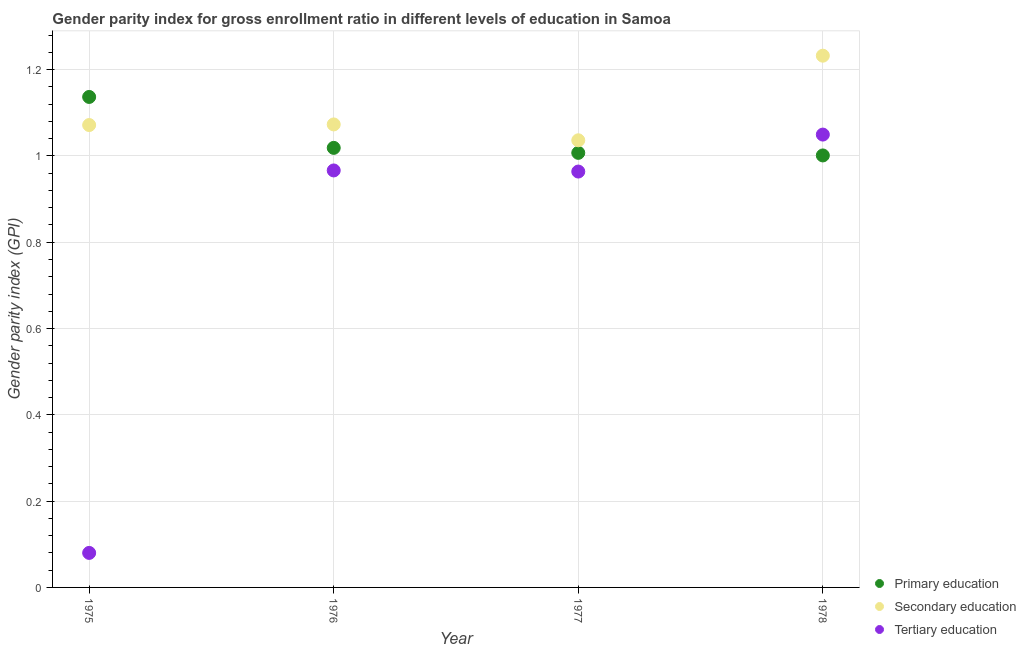How many different coloured dotlines are there?
Provide a short and direct response. 3. Is the number of dotlines equal to the number of legend labels?
Provide a succinct answer. Yes. What is the gender parity index in tertiary education in 1976?
Your answer should be compact. 0.97. Across all years, what is the maximum gender parity index in primary education?
Your answer should be compact. 1.14. Across all years, what is the minimum gender parity index in secondary education?
Provide a succinct answer. 1.04. In which year was the gender parity index in secondary education maximum?
Give a very brief answer. 1978. In which year was the gender parity index in tertiary education minimum?
Your answer should be very brief. 1975. What is the total gender parity index in primary education in the graph?
Provide a succinct answer. 4.16. What is the difference between the gender parity index in tertiary education in 1976 and that in 1977?
Your answer should be compact. 0. What is the difference between the gender parity index in primary education in 1978 and the gender parity index in tertiary education in 1977?
Give a very brief answer. 0.04. What is the average gender parity index in tertiary education per year?
Offer a very short reply. 0.76. In the year 1977, what is the difference between the gender parity index in primary education and gender parity index in tertiary education?
Your answer should be very brief. 0.04. In how many years, is the gender parity index in secondary education greater than 0.2?
Your response must be concise. 4. What is the ratio of the gender parity index in tertiary education in 1975 to that in 1976?
Keep it short and to the point. 0.08. What is the difference between the highest and the second highest gender parity index in secondary education?
Your answer should be very brief. 0.16. What is the difference between the highest and the lowest gender parity index in tertiary education?
Make the answer very short. 0.97. In how many years, is the gender parity index in primary education greater than the average gender parity index in primary education taken over all years?
Make the answer very short. 1. Is the gender parity index in tertiary education strictly greater than the gender parity index in secondary education over the years?
Offer a terse response. No. Is the gender parity index in primary education strictly less than the gender parity index in secondary education over the years?
Your answer should be compact. No. How many dotlines are there?
Ensure brevity in your answer.  3. What is the difference between two consecutive major ticks on the Y-axis?
Keep it short and to the point. 0.2. Does the graph contain any zero values?
Make the answer very short. No. Where does the legend appear in the graph?
Your answer should be very brief. Bottom right. How many legend labels are there?
Your answer should be compact. 3. What is the title of the graph?
Provide a short and direct response. Gender parity index for gross enrollment ratio in different levels of education in Samoa. What is the label or title of the Y-axis?
Give a very brief answer. Gender parity index (GPI). What is the Gender parity index (GPI) of Primary education in 1975?
Offer a very short reply. 1.14. What is the Gender parity index (GPI) in Secondary education in 1975?
Make the answer very short. 1.07. What is the Gender parity index (GPI) of Tertiary education in 1975?
Your answer should be compact. 0.08. What is the Gender parity index (GPI) of Primary education in 1976?
Offer a very short reply. 1.02. What is the Gender parity index (GPI) of Secondary education in 1976?
Keep it short and to the point. 1.07. What is the Gender parity index (GPI) of Tertiary education in 1976?
Your response must be concise. 0.97. What is the Gender parity index (GPI) of Primary education in 1977?
Your answer should be compact. 1.01. What is the Gender parity index (GPI) in Secondary education in 1977?
Keep it short and to the point. 1.04. What is the Gender parity index (GPI) in Tertiary education in 1977?
Your answer should be very brief. 0.96. What is the Gender parity index (GPI) in Primary education in 1978?
Ensure brevity in your answer.  1. What is the Gender parity index (GPI) in Secondary education in 1978?
Keep it short and to the point. 1.23. What is the Gender parity index (GPI) in Tertiary education in 1978?
Give a very brief answer. 1.05. Across all years, what is the maximum Gender parity index (GPI) of Primary education?
Offer a very short reply. 1.14. Across all years, what is the maximum Gender parity index (GPI) of Secondary education?
Provide a succinct answer. 1.23. Across all years, what is the maximum Gender parity index (GPI) in Tertiary education?
Your response must be concise. 1.05. Across all years, what is the minimum Gender parity index (GPI) in Primary education?
Offer a terse response. 1. Across all years, what is the minimum Gender parity index (GPI) in Secondary education?
Keep it short and to the point. 1.04. Across all years, what is the minimum Gender parity index (GPI) in Tertiary education?
Offer a terse response. 0.08. What is the total Gender parity index (GPI) in Primary education in the graph?
Offer a terse response. 4.16. What is the total Gender parity index (GPI) in Secondary education in the graph?
Keep it short and to the point. 4.41. What is the total Gender parity index (GPI) of Tertiary education in the graph?
Your response must be concise. 3.06. What is the difference between the Gender parity index (GPI) of Primary education in 1975 and that in 1976?
Provide a short and direct response. 0.12. What is the difference between the Gender parity index (GPI) of Secondary education in 1975 and that in 1976?
Offer a terse response. -0. What is the difference between the Gender parity index (GPI) in Tertiary education in 1975 and that in 1976?
Provide a succinct answer. -0.89. What is the difference between the Gender parity index (GPI) in Primary education in 1975 and that in 1977?
Offer a very short reply. 0.13. What is the difference between the Gender parity index (GPI) in Secondary education in 1975 and that in 1977?
Make the answer very short. 0.04. What is the difference between the Gender parity index (GPI) in Tertiary education in 1975 and that in 1977?
Ensure brevity in your answer.  -0.88. What is the difference between the Gender parity index (GPI) of Primary education in 1975 and that in 1978?
Make the answer very short. 0.14. What is the difference between the Gender parity index (GPI) of Secondary education in 1975 and that in 1978?
Your answer should be compact. -0.16. What is the difference between the Gender parity index (GPI) of Tertiary education in 1975 and that in 1978?
Ensure brevity in your answer.  -0.97. What is the difference between the Gender parity index (GPI) of Primary education in 1976 and that in 1977?
Your answer should be compact. 0.01. What is the difference between the Gender parity index (GPI) in Secondary education in 1976 and that in 1977?
Make the answer very short. 0.04. What is the difference between the Gender parity index (GPI) in Tertiary education in 1976 and that in 1977?
Keep it short and to the point. 0. What is the difference between the Gender parity index (GPI) in Primary education in 1976 and that in 1978?
Make the answer very short. 0.02. What is the difference between the Gender parity index (GPI) in Secondary education in 1976 and that in 1978?
Your response must be concise. -0.16. What is the difference between the Gender parity index (GPI) of Tertiary education in 1976 and that in 1978?
Your answer should be very brief. -0.08. What is the difference between the Gender parity index (GPI) in Primary education in 1977 and that in 1978?
Your answer should be very brief. 0.01. What is the difference between the Gender parity index (GPI) in Secondary education in 1977 and that in 1978?
Provide a short and direct response. -0.2. What is the difference between the Gender parity index (GPI) of Tertiary education in 1977 and that in 1978?
Offer a very short reply. -0.09. What is the difference between the Gender parity index (GPI) in Primary education in 1975 and the Gender parity index (GPI) in Secondary education in 1976?
Your response must be concise. 0.06. What is the difference between the Gender parity index (GPI) in Primary education in 1975 and the Gender parity index (GPI) in Tertiary education in 1976?
Offer a terse response. 0.17. What is the difference between the Gender parity index (GPI) in Secondary education in 1975 and the Gender parity index (GPI) in Tertiary education in 1976?
Your response must be concise. 0.11. What is the difference between the Gender parity index (GPI) in Primary education in 1975 and the Gender parity index (GPI) in Secondary education in 1977?
Make the answer very short. 0.1. What is the difference between the Gender parity index (GPI) in Primary education in 1975 and the Gender parity index (GPI) in Tertiary education in 1977?
Make the answer very short. 0.17. What is the difference between the Gender parity index (GPI) in Secondary education in 1975 and the Gender parity index (GPI) in Tertiary education in 1977?
Offer a very short reply. 0.11. What is the difference between the Gender parity index (GPI) of Primary education in 1975 and the Gender parity index (GPI) of Secondary education in 1978?
Ensure brevity in your answer.  -0.1. What is the difference between the Gender parity index (GPI) in Primary education in 1975 and the Gender parity index (GPI) in Tertiary education in 1978?
Make the answer very short. 0.09. What is the difference between the Gender parity index (GPI) in Secondary education in 1975 and the Gender parity index (GPI) in Tertiary education in 1978?
Offer a very short reply. 0.02. What is the difference between the Gender parity index (GPI) of Primary education in 1976 and the Gender parity index (GPI) of Secondary education in 1977?
Ensure brevity in your answer.  -0.02. What is the difference between the Gender parity index (GPI) of Primary education in 1976 and the Gender parity index (GPI) of Tertiary education in 1977?
Give a very brief answer. 0.05. What is the difference between the Gender parity index (GPI) in Secondary education in 1976 and the Gender parity index (GPI) in Tertiary education in 1977?
Give a very brief answer. 0.11. What is the difference between the Gender parity index (GPI) of Primary education in 1976 and the Gender parity index (GPI) of Secondary education in 1978?
Keep it short and to the point. -0.21. What is the difference between the Gender parity index (GPI) of Primary education in 1976 and the Gender parity index (GPI) of Tertiary education in 1978?
Provide a short and direct response. -0.03. What is the difference between the Gender parity index (GPI) of Secondary education in 1976 and the Gender parity index (GPI) of Tertiary education in 1978?
Provide a short and direct response. 0.02. What is the difference between the Gender parity index (GPI) of Primary education in 1977 and the Gender parity index (GPI) of Secondary education in 1978?
Provide a succinct answer. -0.23. What is the difference between the Gender parity index (GPI) in Primary education in 1977 and the Gender parity index (GPI) in Tertiary education in 1978?
Offer a very short reply. -0.04. What is the difference between the Gender parity index (GPI) in Secondary education in 1977 and the Gender parity index (GPI) in Tertiary education in 1978?
Keep it short and to the point. -0.01. What is the average Gender parity index (GPI) of Primary education per year?
Your response must be concise. 1.04. What is the average Gender parity index (GPI) of Secondary education per year?
Make the answer very short. 1.1. What is the average Gender parity index (GPI) of Tertiary education per year?
Your answer should be compact. 0.76. In the year 1975, what is the difference between the Gender parity index (GPI) of Primary education and Gender parity index (GPI) of Secondary education?
Offer a very short reply. 0.07. In the year 1975, what is the difference between the Gender parity index (GPI) in Primary education and Gender parity index (GPI) in Tertiary education?
Provide a short and direct response. 1.06. In the year 1975, what is the difference between the Gender parity index (GPI) of Secondary education and Gender parity index (GPI) of Tertiary education?
Provide a short and direct response. 0.99. In the year 1976, what is the difference between the Gender parity index (GPI) of Primary education and Gender parity index (GPI) of Secondary education?
Make the answer very short. -0.05. In the year 1976, what is the difference between the Gender parity index (GPI) in Primary education and Gender parity index (GPI) in Tertiary education?
Your answer should be very brief. 0.05. In the year 1976, what is the difference between the Gender parity index (GPI) of Secondary education and Gender parity index (GPI) of Tertiary education?
Offer a very short reply. 0.11. In the year 1977, what is the difference between the Gender parity index (GPI) of Primary education and Gender parity index (GPI) of Secondary education?
Make the answer very short. -0.03. In the year 1977, what is the difference between the Gender parity index (GPI) in Primary education and Gender parity index (GPI) in Tertiary education?
Offer a terse response. 0.04. In the year 1977, what is the difference between the Gender parity index (GPI) of Secondary education and Gender parity index (GPI) of Tertiary education?
Ensure brevity in your answer.  0.07. In the year 1978, what is the difference between the Gender parity index (GPI) in Primary education and Gender parity index (GPI) in Secondary education?
Provide a short and direct response. -0.23. In the year 1978, what is the difference between the Gender parity index (GPI) of Primary education and Gender parity index (GPI) of Tertiary education?
Ensure brevity in your answer.  -0.05. In the year 1978, what is the difference between the Gender parity index (GPI) of Secondary education and Gender parity index (GPI) of Tertiary education?
Give a very brief answer. 0.18. What is the ratio of the Gender parity index (GPI) of Primary education in 1975 to that in 1976?
Offer a terse response. 1.12. What is the ratio of the Gender parity index (GPI) of Secondary education in 1975 to that in 1976?
Keep it short and to the point. 1. What is the ratio of the Gender parity index (GPI) of Tertiary education in 1975 to that in 1976?
Keep it short and to the point. 0.08. What is the ratio of the Gender parity index (GPI) in Primary education in 1975 to that in 1977?
Provide a succinct answer. 1.13. What is the ratio of the Gender parity index (GPI) of Secondary education in 1975 to that in 1977?
Your response must be concise. 1.03. What is the ratio of the Gender parity index (GPI) in Tertiary education in 1975 to that in 1977?
Your response must be concise. 0.08. What is the ratio of the Gender parity index (GPI) of Primary education in 1975 to that in 1978?
Give a very brief answer. 1.14. What is the ratio of the Gender parity index (GPI) in Secondary education in 1975 to that in 1978?
Make the answer very short. 0.87. What is the ratio of the Gender parity index (GPI) of Tertiary education in 1975 to that in 1978?
Keep it short and to the point. 0.08. What is the ratio of the Gender parity index (GPI) in Primary education in 1976 to that in 1977?
Your answer should be compact. 1.01. What is the ratio of the Gender parity index (GPI) in Secondary education in 1976 to that in 1977?
Give a very brief answer. 1.04. What is the ratio of the Gender parity index (GPI) in Primary education in 1976 to that in 1978?
Provide a short and direct response. 1.02. What is the ratio of the Gender parity index (GPI) of Secondary education in 1976 to that in 1978?
Your response must be concise. 0.87. What is the ratio of the Gender parity index (GPI) in Tertiary education in 1976 to that in 1978?
Offer a very short reply. 0.92. What is the ratio of the Gender parity index (GPI) in Secondary education in 1977 to that in 1978?
Provide a short and direct response. 0.84. What is the ratio of the Gender parity index (GPI) of Tertiary education in 1977 to that in 1978?
Offer a very short reply. 0.92. What is the difference between the highest and the second highest Gender parity index (GPI) in Primary education?
Your answer should be compact. 0.12. What is the difference between the highest and the second highest Gender parity index (GPI) of Secondary education?
Give a very brief answer. 0.16. What is the difference between the highest and the second highest Gender parity index (GPI) in Tertiary education?
Provide a succinct answer. 0.08. What is the difference between the highest and the lowest Gender parity index (GPI) of Primary education?
Keep it short and to the point. 0.14. What is the difference between the highest and the lowest Gender parity index (GPI) of Secondary education?
Give a very brief answer. 0.2. What is the difference between the highest and the lowest Gender parity index (GPI) in Tertiary education?
Your answer should be very brief. 0.97. 